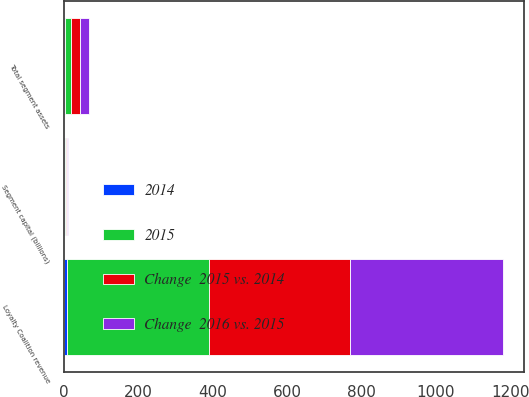Convert chart. <chart><loc_0><loc_0><loc_500><loc_500><stacked_bar_chart><ecel><fcel>Loyalty Coalition revenue<fcel>Total segment assets<fcel>Segment capital (billions)<nl><fcel>Change  2016 vs. 2015<fcel>410<fcel>24.3<fcel>2.5<nl><fcel>Change  2015 vs. 2014<fcel>378<fcel>23.5<fcel>2.4<nl><fcel>2015<fcel>383<fcel>17.8<fcel>2.1<nl><fcel>2014<fcel>8<fcel>3<fcel>4<nl></chart> 